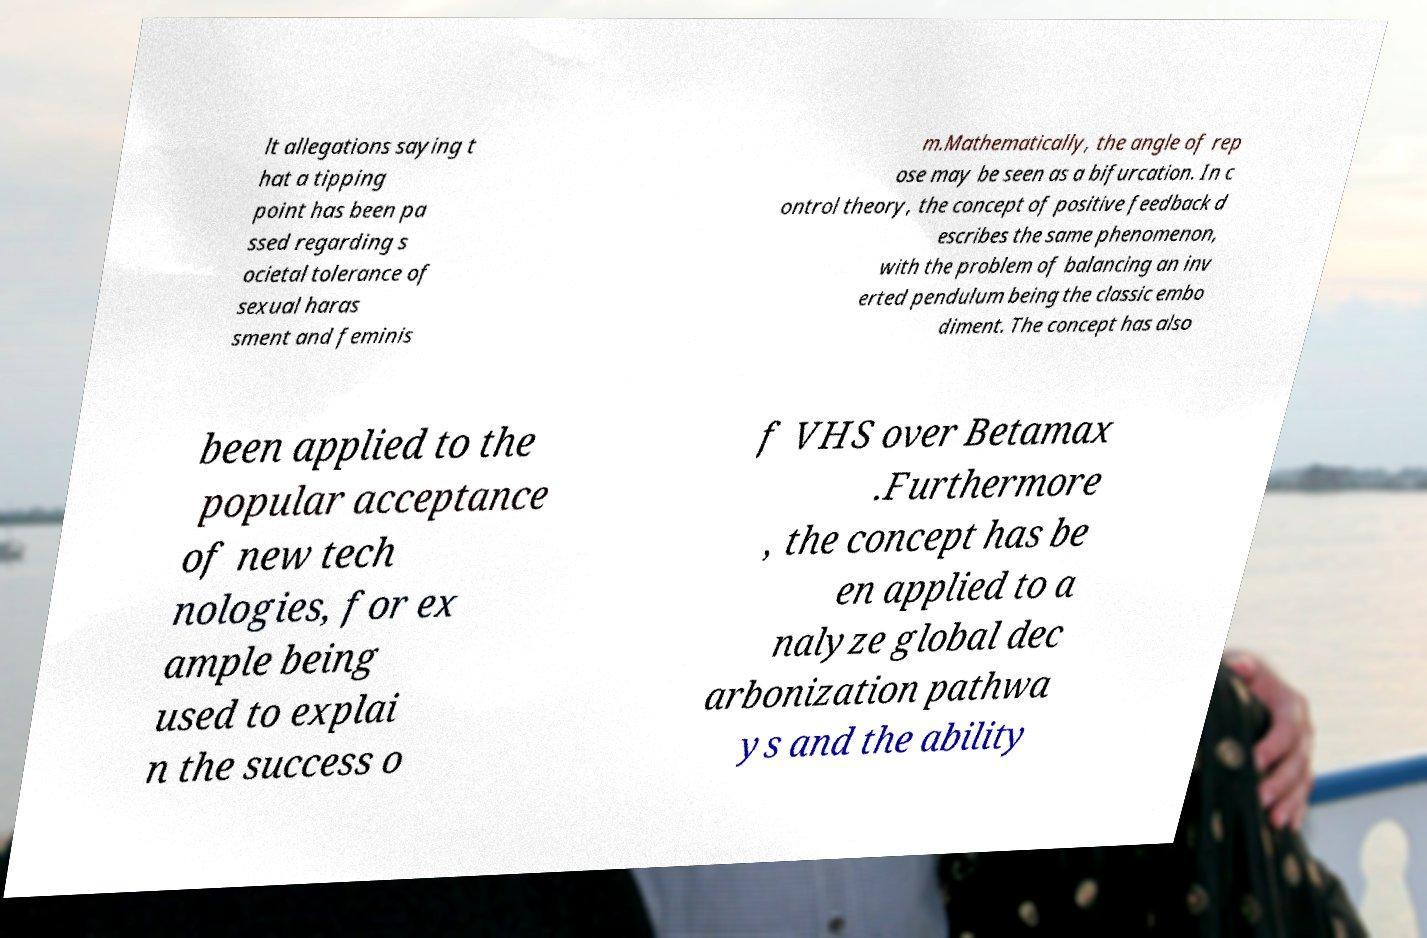Could you assist in decoding the text presented in this image and type it out clearly? lt allegations saying t hat a tipping point has been pa ssed regarding s ocietal tolerance of sexual haras sment and feminis m.Mathematically, the angle of rep ose may be seen as a bifurcation. In c ontrol theory, the concept of positive feedback d escribes the same phenomenon, with the problem of balancing an inv erted pendulum being the classic embo diment. The concept has also been applied to the popular acceptance of new tech nologies, for ex ample being used to explai n the success o f VHS over Betamax .Furthermore , the concept has be en applied to a nalyze global dec arbonization pathwa ys and the ability 